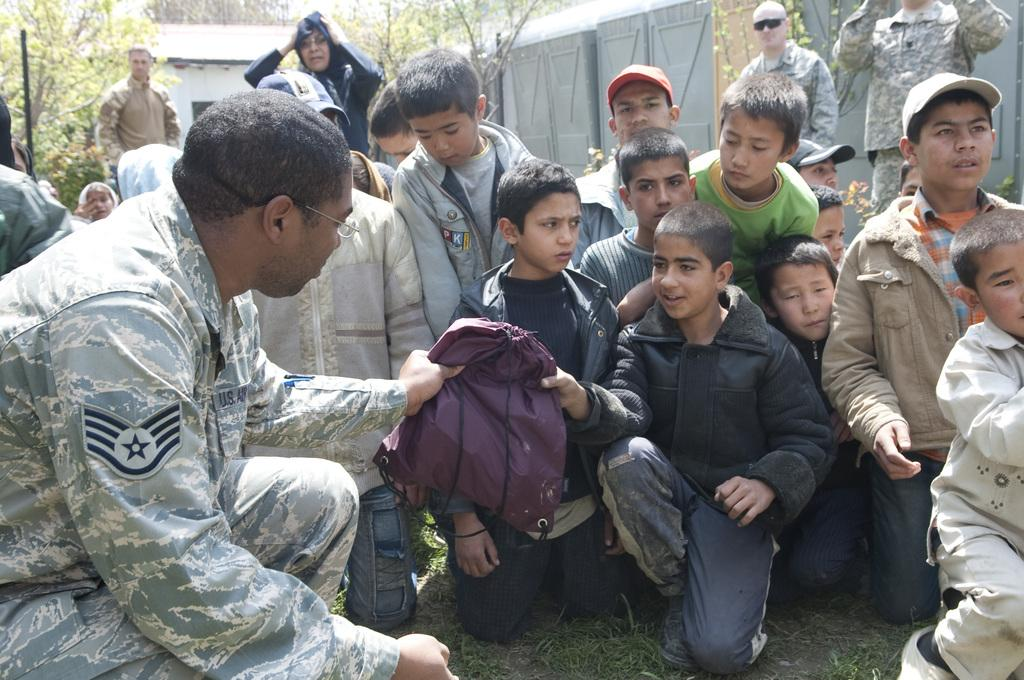How many kids are present in the image? There are many kids in the image. What is the man holding in the image? The man is holding a bag in the image. Can you describe the background of the image? There are other people, buildings, a wall, and trees in the background of the image. What type of patch can be seen on the wall in the image? There is no patch visible on the wall in the image. 